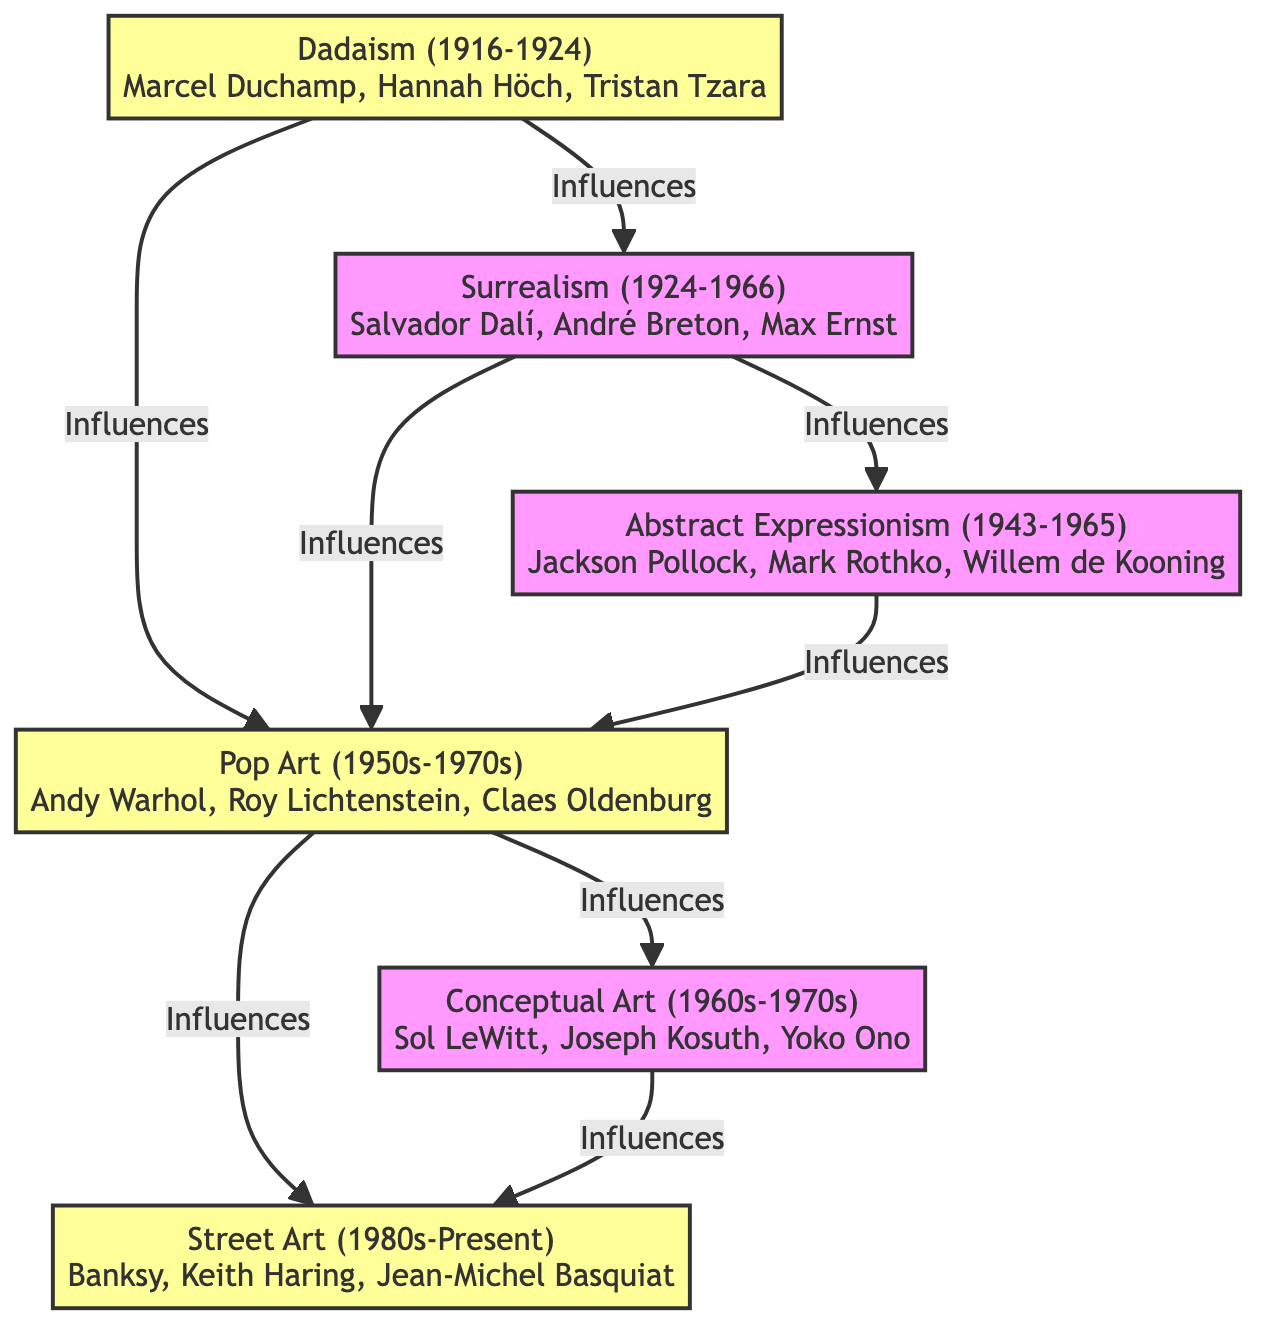What are the dates for Dadaism? The diagram shows that Dadaism spans the years 1916 to 1924, which can be found within the node labeled 'Dadaism'.
Answer: 1916-1924 Who are the key artists of Pop Art? By examining the Pop Art node in the diagram, we see the key artists listed are Andy Warhol, Roy Lichtenstein, and Claes Oldenburg.
Answer: Andy Warhol, Roy Lichtenstein, Claes Oldenburg How many movements influenced Street Art? Looking at the arrows leading into the Street Art node reveals that it is influenced by two movements, Pop Art and Conceptual Art.
Answer: 2 Which movement came directly after Surrealism? Tracing the flow from Surrealism, the next connected node is Abstract Expressionism, indicating that it directly follows Surrealism.
Answer: Abstract Expressionism Which movement influenced both Pop Art and Street Art? By inspecting the Pop Art and Street Art nodes, we see that the influencing movement for both of them is Pop Art, as indicated by the arrows leading towards them.
Answer: Pop Art How many key artists are associated with Abstract Expressionism? The node for Abstract Expressionism lists three key artists: Jackson Pollock, Mark Rothko, and Willem de Kooning. There are three names in total.
Answer: 3 Which two movements influenced Surrealism? Surrealism is influenced by the movement directly before it, which is Dadaism; that is the only influence noted in its node.
Answer: Dadaism What is the primary influence of Conceptual Art? The Conceptual Art node specifies that it is influenced mainly by Pop Art, which is the only listed influence for it.
Answer: Pop Art What are the dates of Street Art? The Street Art node clearly states it spans the years from the 1980s to the present, and this can be directly read off the information in the node.
Answer: 1980s-Present 